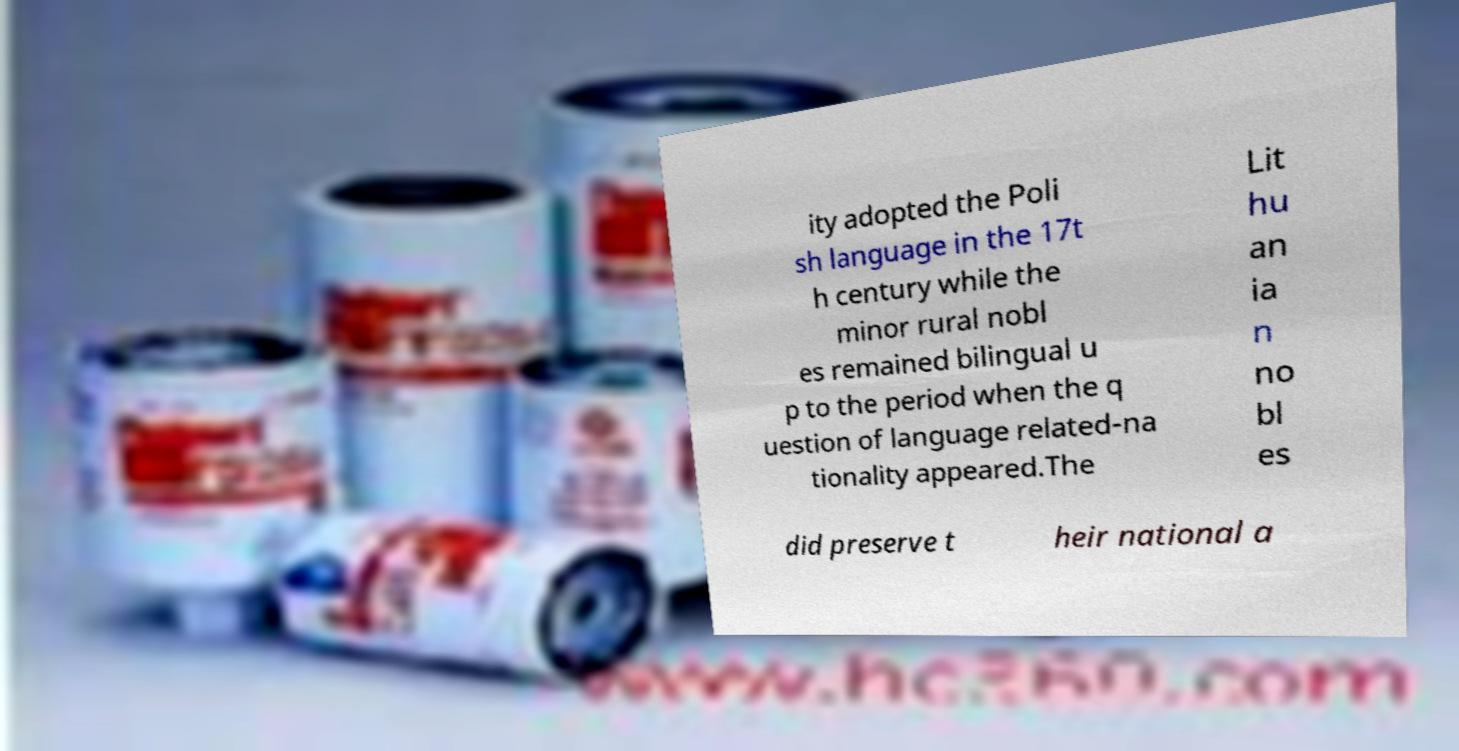I need the written content from this picture converted into text. Can you do that? ity adopted the Poli sh language in the 17t h century while the minor rural nobl es remained bilingual u p to the period when the q uestion of language related-na tionality appeared.The Lit hu an ia n no bl es did preserve t heir national a 